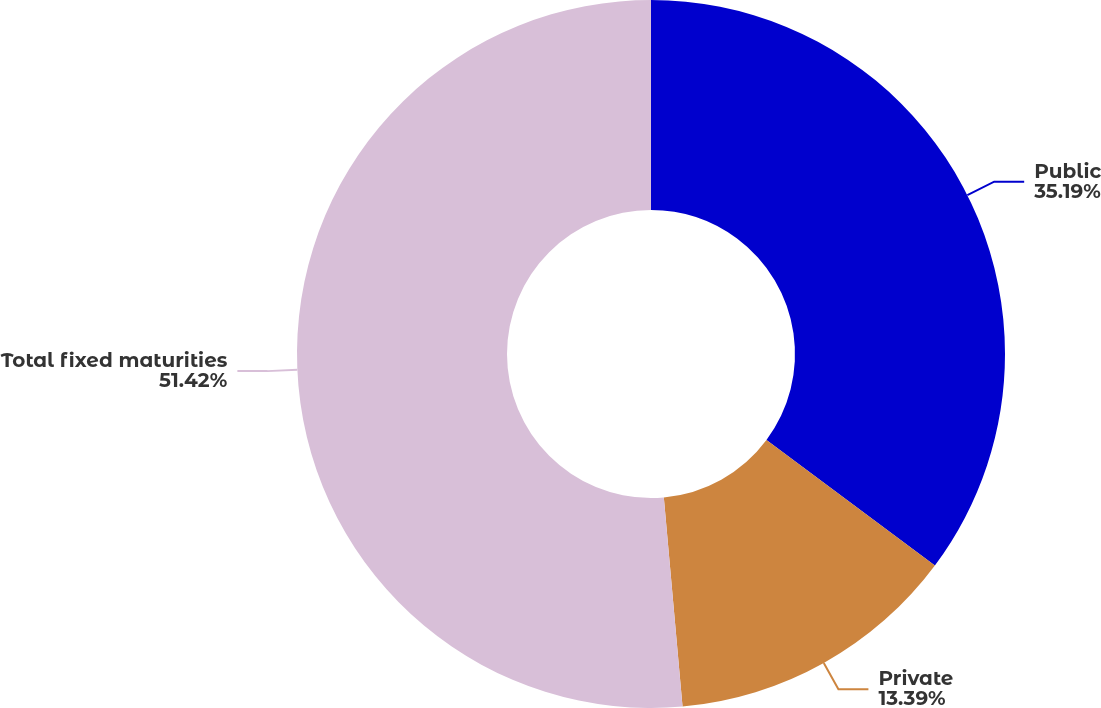Convert chart to OTSL. <chart><loc_0><loc_0><loc_500><loc_500><pie_chart><fcel>Public<fcel>Private<fcel>Total fixed maturities<nl><fcel>35.19%<fcel>13.39%<fcel>51.42%<nl></chart> 